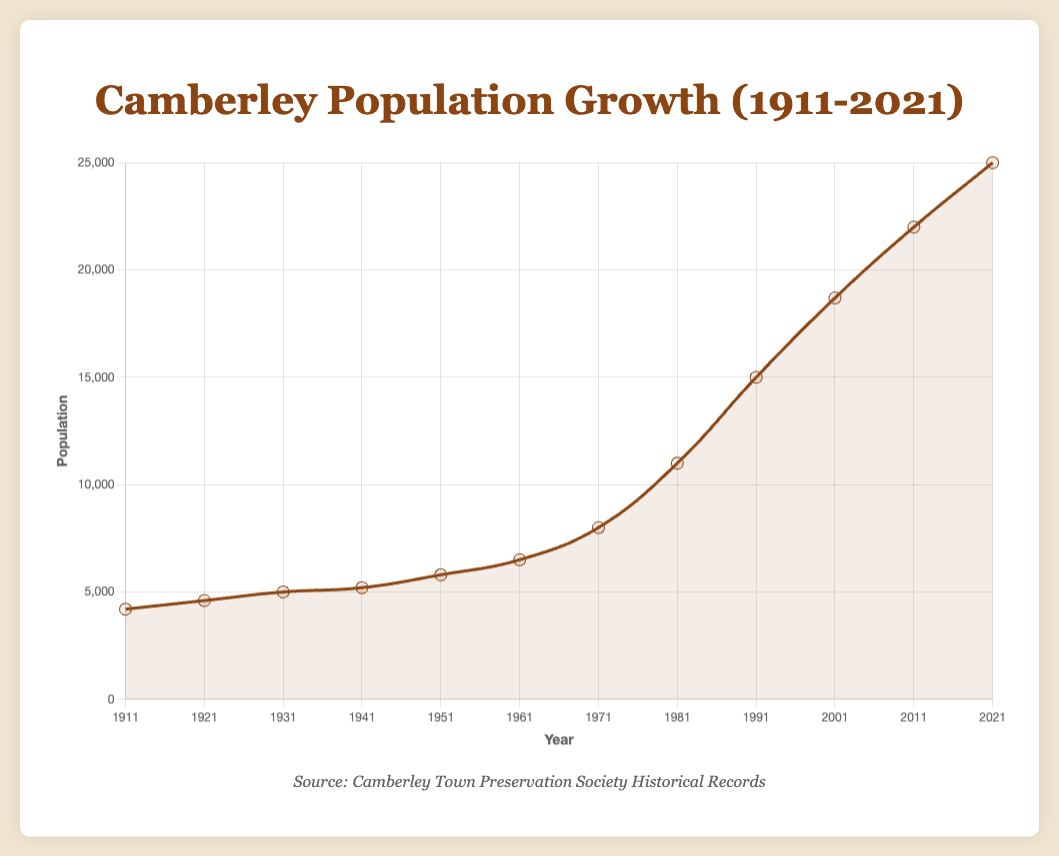What is the general trend in Camberley's population from 1911 to 2021? The plot shows a clear upward trend in the population of Camberley from 1911 to 2021. The population consistently increases over each decade.
Answer: Upward trend During which decade did Camberley experience the highest percentage increase in population? Based on the decadal breakdown, the highest percentage increase was from 1971 to 1981, where the population grew from 8000 to 11000, a 37.50% increase.
Answer: 1971-1981 How does the population change from 1941 to 1951 compare to the change from 1921 to 1931? From 1941 to 1951, the population increased by 600 (5200 to 5800), a percentage change of 11.54%. From 1921 to 1931, the population increased by 400 (4600 to 5000), a percentage change of 8.70%. Thus, the increase during 1941-1951 was both higher in absolute numbers and percentage.
Answer: 1941-1951 saw greater increase What is the percentage change in population from 1961 to 1971, and how does it compare to the percentage change from 1981 to 1991? From 1961 to 1971, the population grew by 1500 (6500 to 8000), a 23.08% increase. From 1981 to 1991, the population grew by 4000 (11000 to 15000), a 36.36% increase. Therefore, the increase from 1981 to 1991 was greater in percentage terms.
Answer: 1981-1991 had a greater percentage change What was the population of Camberley in 1911, and how does it compare to the population in 2021? In 1911, the population was 4200. In 2021, it was 25000. Therefore, the population increased by 20800 over this period.
Answer: Increased by 20800 What visual attributes indicate a significant population growth in certain decades? The steeper slopes and larger vertical distances between points indicate significant population growth in certain decades, such as 1961-1971 and 1981-1991.
Answer: Steeper slopes and larger vertical distances Calculate the average population for the entire period from 1911 to 2021. Summing up the populations for all given years (4200+4600+5000+5200+5800+6500+8000+11000+15000+18700+22000+25000) gives a total of 136000. Dividing by the number of periods (12) gives an average of approximately 11333.33.
Answer: 11333.33 Which decade had the smallest population increase, and what was the increase? The smallest population increase occurred from 1931 to 1941, where the population grew by only 200 (5200 to 5400), a 4.00% increase.
Answer: 1931-1941, increase of 200 Compare the population of Camberley in 1931 to 2021 and indicate the factor by which it has grown. The population in 1931 was 5000, and in 2021 it was 25000. Dividing 25000 by 5000 shows that the population grew by a factor of 5 over this period.
Answer: Grew by a factor of 5 